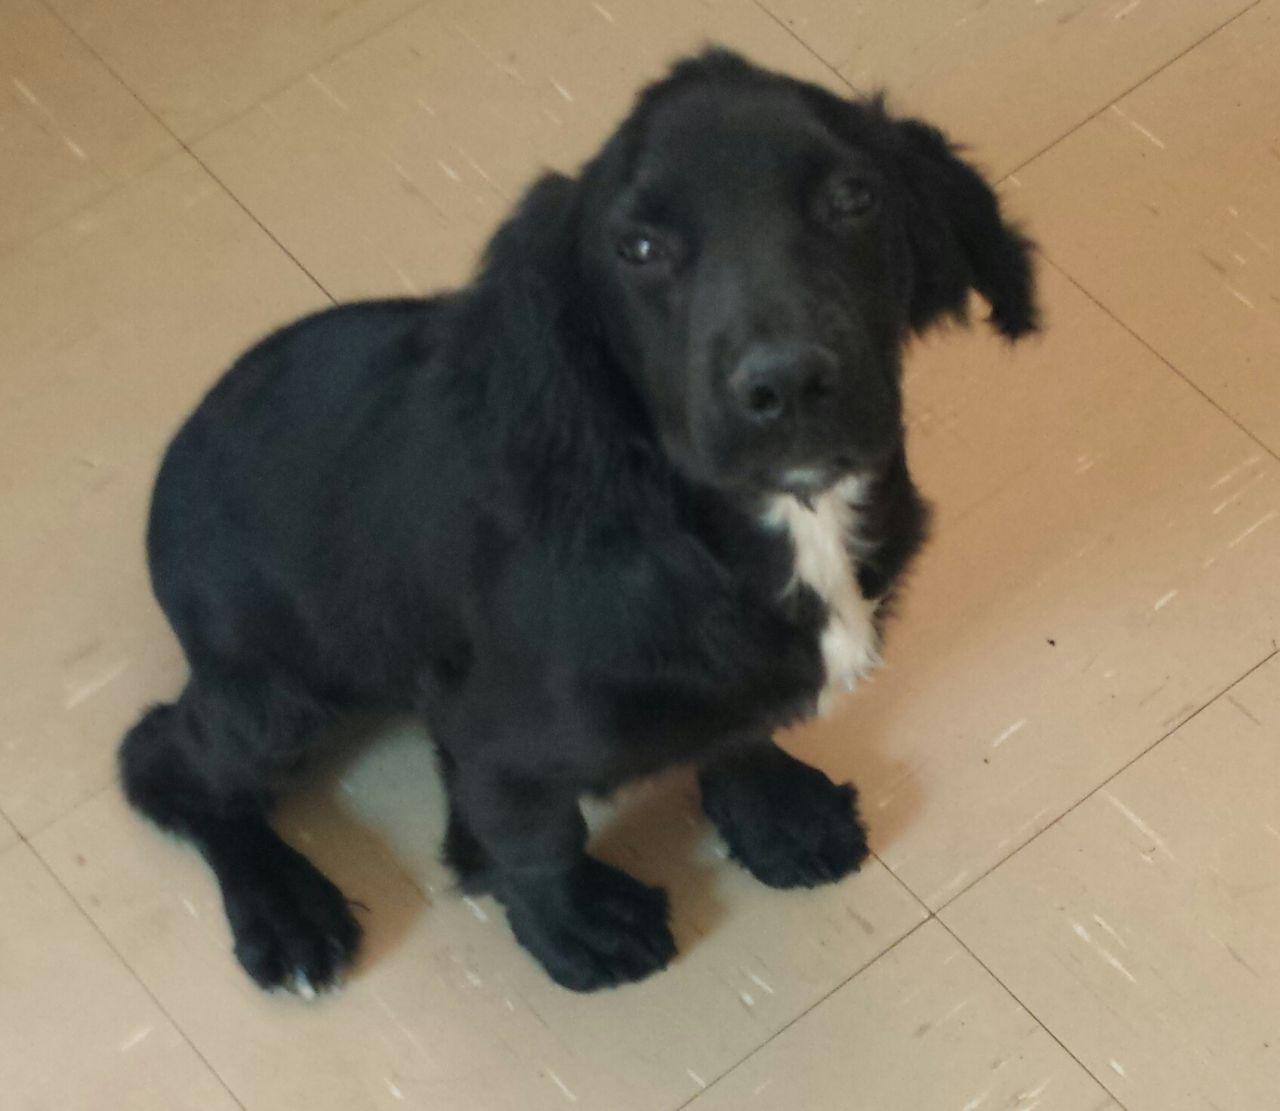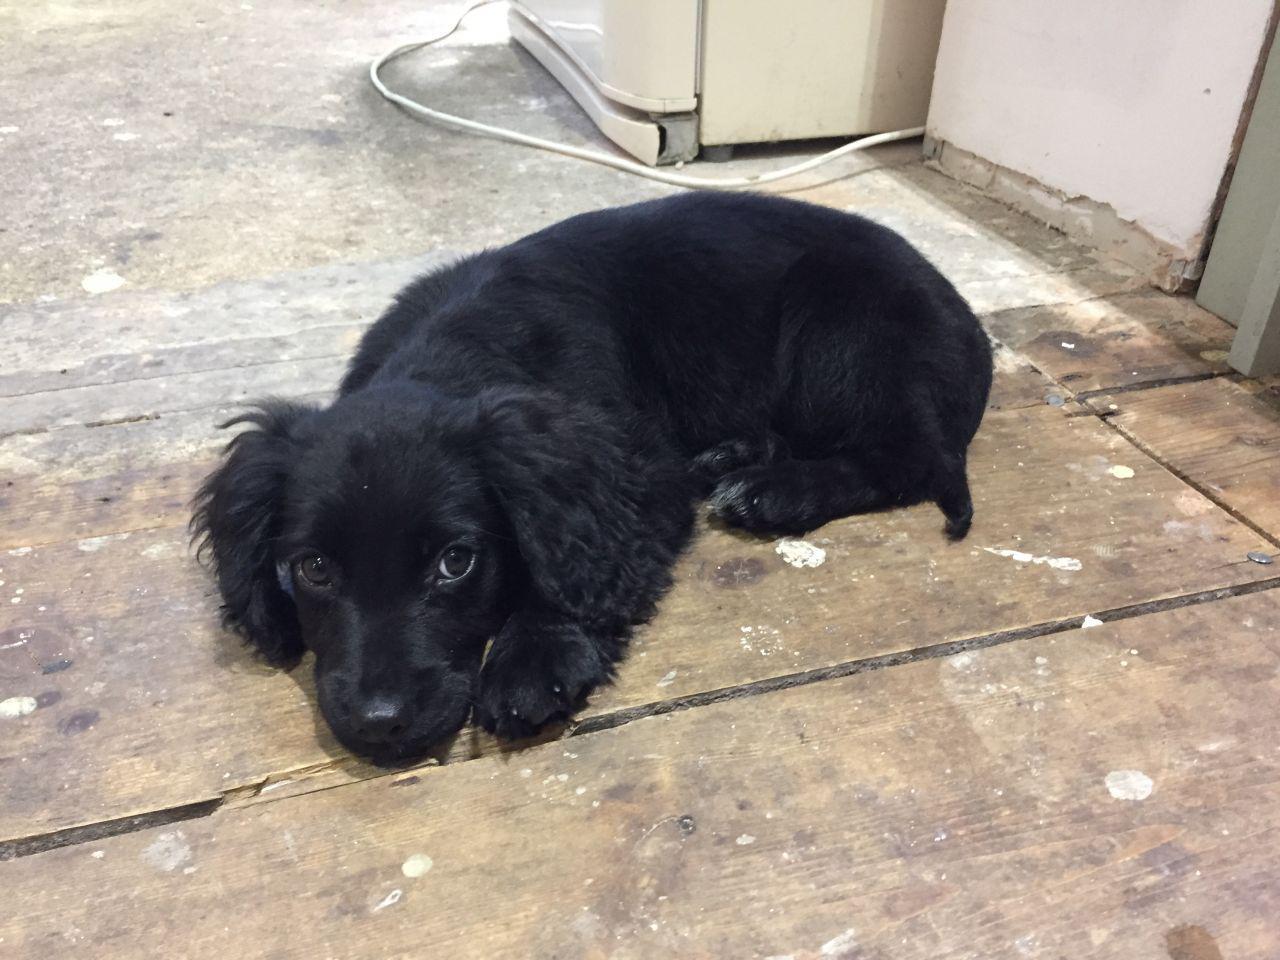The first image is the image on the left, the second image is the image on the right. Considering the images on both sides, is "There are more black dogs in the right image than in the left." valid? Answer yes or no. No. The first image is the image on the left, the second image is the image on the right. Given the left and right images, does the statement "The black dog in the image on the left is outside on a sunny day." hold true? Answer yes or no. No. 